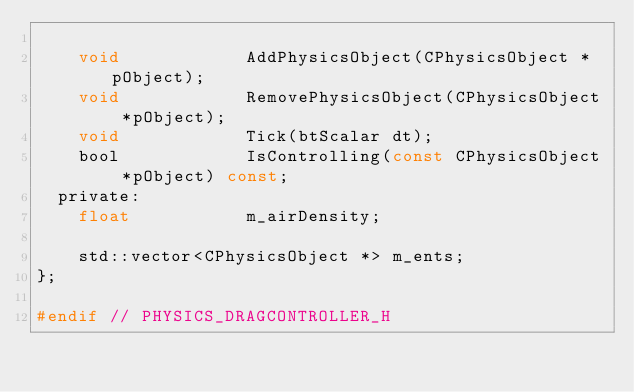Convert code to text. <code><loc_0><loc_0><loc_500><loc_500><_C_>
		void						AddPhysicsObject(CPhysicsObject *pObject);
		void						RemovePhysicsObject(CPhysicsObject *pObject);
		void						Tick(btScalar dt);
		bool						IsControlling(const CPhysicsObject *pObject) const;
	private:
		float						m_airDensity;

		std::vector<CPhysicsObject *> m_ents;
};

#endif // PHYSICS_DRAGCONTROLLER_H</code> 